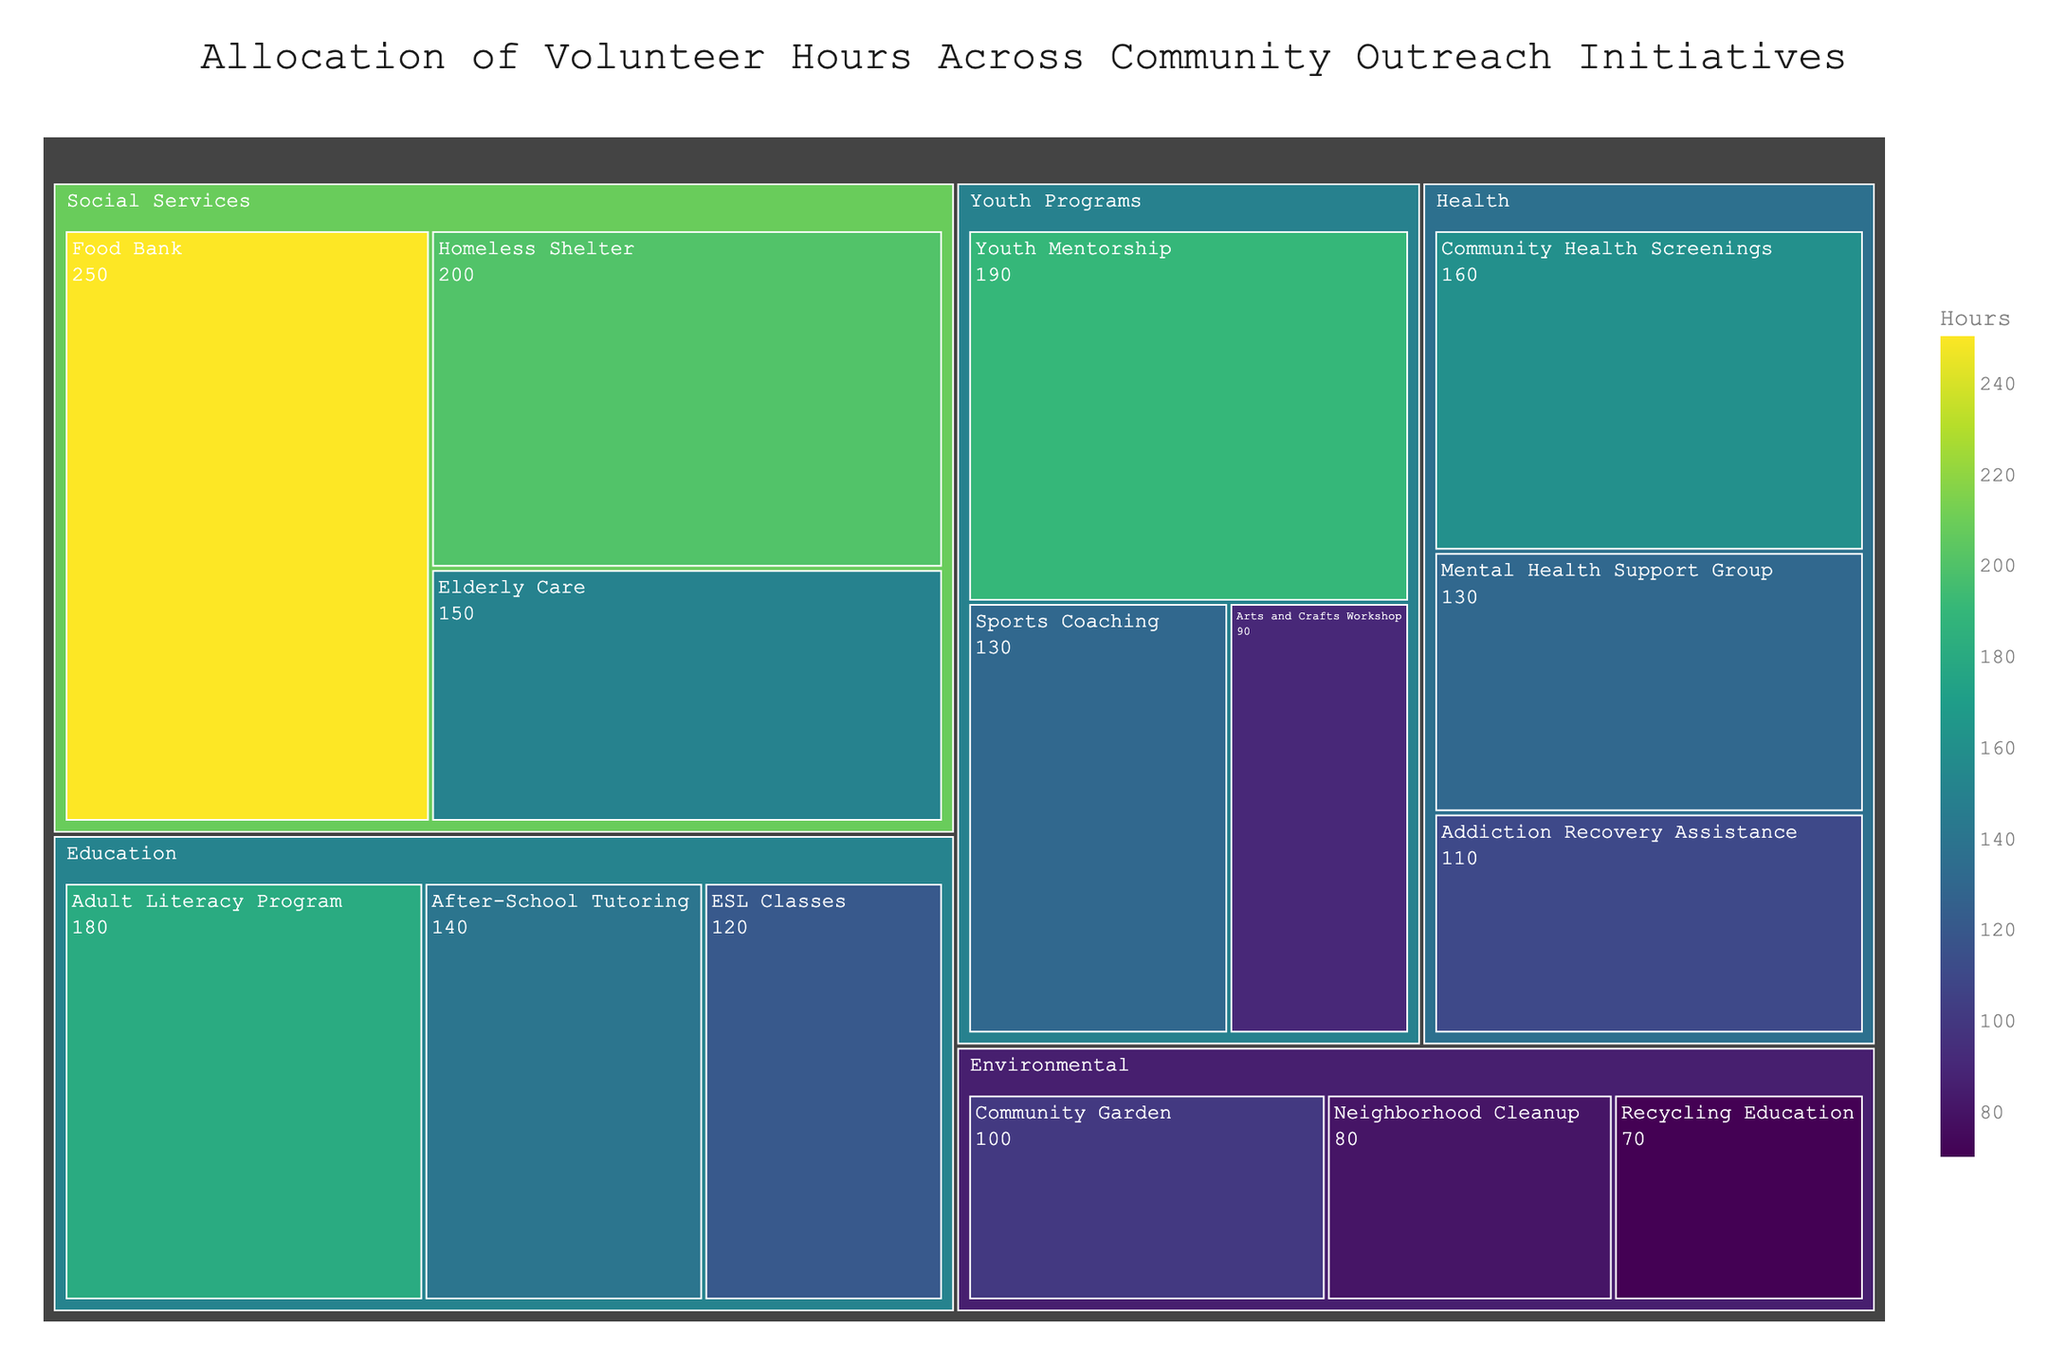What is the total number of volunteer hours dedicated to Social Services initiatives? To find the total hours for Social Services, sum the hours for all initiatives under the Social Services category: 250 (Food Bank) + 200 (Homeless Shelter) + 150 (Elderly Care) = 600 hours
Answer: 600 hours Which initiative under Health has the highest number of volunteer hours? Compare the volunteer hours among the Health initiatives: Community Health Screenings (160), Mental Health Support Group (130), and Addiction Recovery Assistance (110). The highest is 160 hours for Community Health Screenings
Answer: Community Health Screenings What are the two initiatives with the least number of volunteer hours in the entire treemap? Identify the initiatives with the smallest hours: Recycling Education (70), Neighborhood Cleanup (80), and Arts and Crafts Workshop (90). The two smallest are 70 and 80 hours, which belong to Recycling Education and Neighborhood Cleanup, respectively
Answer: Recycling Education and Neighborhood Cleanup Which category has the highest total volunteer hours and what is the sum? Sum the hours for each category: 
- Social Services: 250 + 200 + 150 = 600
- Education: 180 + 140 + 120 = 440
- Health: 160 + 130 + 110 = 400
- Environmental: 100 + 80 + 70 = 250
- Youth Programs: 190 + 130 + 90 = 410
The category with the highest total hours is Social Services with 600 hours
Answer: Social Services, 600 hours What are the three initiatives with the most volunteer hours and their respective hours? Identify the top three initiatives with the highest hours: Food Bank (250), Homeless Shelter (200), Youth Mentorship (190)
Answer: Food Bank (250), Homeless Shelter (200), Youth Mentorship (190) How many more volunteer hours are allocated to Food Bank compared to Arts and Crafts Workshop? Subtract the hours for Arts and Crafts Workshop from those for Food Bank: 250 (Food Bank) - 90 (Arts and Crafts Workshop) = 160 hours
Answer: 160 hours What is the average number of volunteer hours dedicated to Education initiatives? Find the total hours for Education and divide by the number of initiatives: (180 + 140 + 120) / 3 = 440 / 3 ≈ 146.67 hours
Answer: 146.67 hours Compare the total volunteer hours allocated to Youth Programs and Health. Which category has more hours and by how much? Calculate the total hours for both categories:
- Youth Programs: 190 + 130 + 90 = 410
- Health: 160 + 130 + 110 = 400
Youth Programs has 410 - 400 = 10 more hours than Health
Answer: Youth Programs, 10 hours What is the median number of volunteer hours for the five categories listed? List all total hours:
- Social Services: 600
- Education: 440
- Health: 400
- Environmental: 250
- Youth Programs: 410
Order them: 250, 400, 410, 440, 600. The median is the middle value, which is 410 hours
Answer: 410 hours 